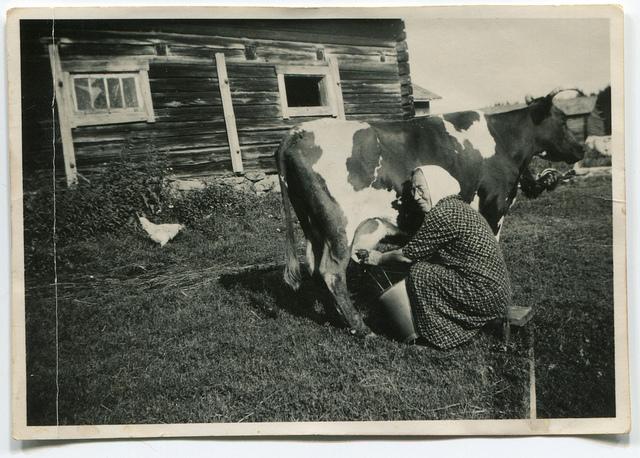Are these horns too big for this animal?
Quick response, please. No. What color is the lady's bonnet?
Answer briefly. White. What is the lady doing to the cow?
Answer briefly. Milking. Is the picture black and white?
Write a very short answer. Yes. 